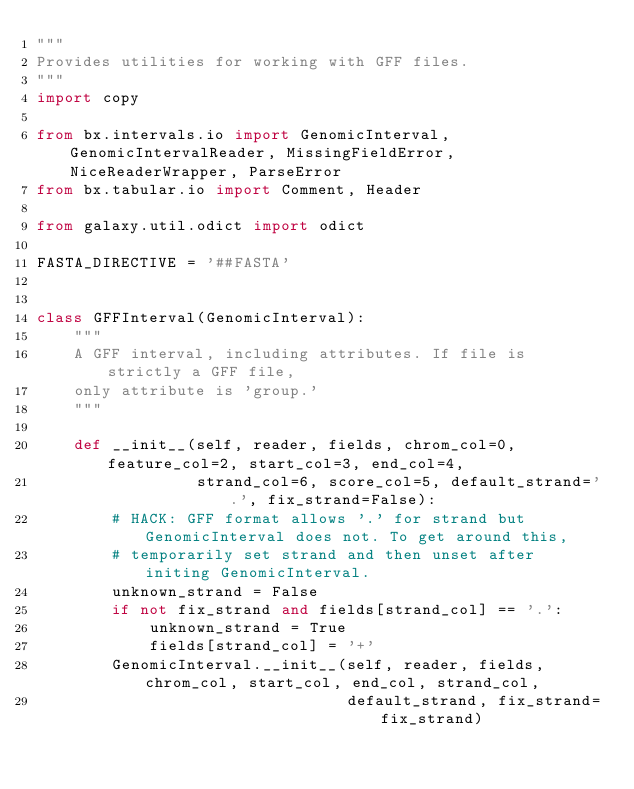<code> <loc_0><loc_0><loc_500><loc_500><_Python_>"""
Provides utilities for working with GFF files.
"""
import copy

from bx.intervals.io import GenomicInterval, GenomicIntervalReader, MissingFieldError, NiceReaderWrapper, ParseError
from bx.tabular.io import Comment, Header

from galaxy.util.odict import odict

FASTA_DIRECTIVE = '##FASTA'


class GFFInterval(GenomicInterval):
    """
    A GFF interval, including attributes. If file is strictly a GFF file,
    only attribute is 'group.'
    """

    def __init__(self, reader, fields, chrom_col=0, feature_col=2, start_col=3, end_col=4,
                 strand_col=6, score_col=5, default_strand='.', fix_strand=False):
        # HACK: GFF format allows '.' for strand but GenomicInterval does not. To get around this,
        # temporarily set strand and then unset after initing GenomicInterval.
        unknown_strand = False
        if not fix_strand and fields[strand_col] == '.':
            unknown_strand = True
            fields[strand_col] = '+'
        GenomicInterval.__init__(self, reader, fields, chrom_col, start_col, end_col, strand_col,
                                 default_strand, fix_strand=fix_strand)</code> 